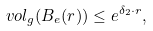<formula> <loc_0><loc_0><loc_500><loc_500>v o l _ { g } ( B _ { e } ( r ) ) \leq e ^ { \delta _ { 2 } \cdot r } ,</formula> 